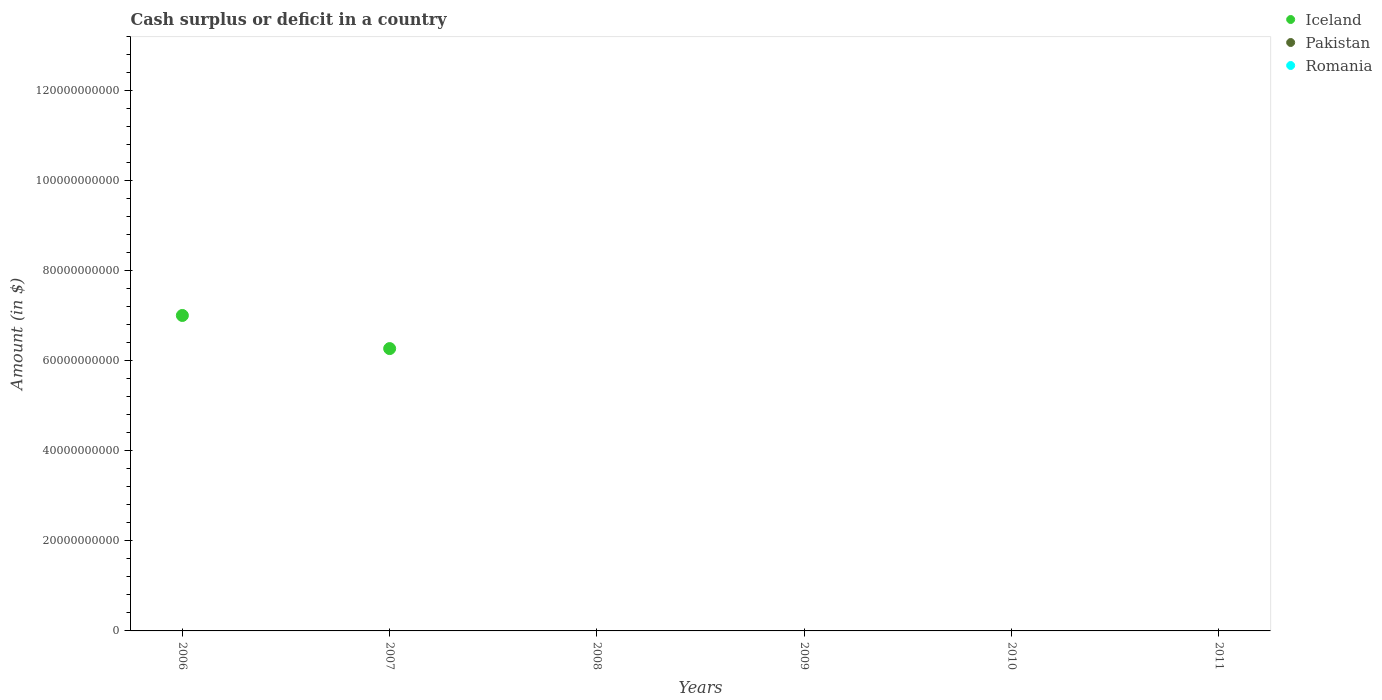Across all years, what is the maximum amount of cash surplus or deficit in Iceland?
Your answer should be very brief. 7.01e+1. What is the total amount of cash surplus or deficit in Romania in the graph?
Offer a terse response. 0. What is the difference between the amount of cash surplus or deficit in Romania in 2007 and the amount of cash surplus or deficit in Iceland in 2010?
Provide a succinct answer. 0. What is the average amount of cash surplus or deficit in Iceland per year?
Keep it short and to the point. 2.21e+1. Is the amount of cash surplus or deficit in Iceland in 2006 less than that in 2007?
Offer a very short reply. No. What is the difference between the highest and the lowest amount of cash surplus or deficit in Iceland?
Provide a short and direct response. 7.01e+1. Is it the case that in every year, the sum of the amount of cash surplus or deficit in Iceland and amount of cash surplus or deficit in Romania  is greater than the amount of cash surplus or deficit in Pakistan?
Give a very brief answer. No. Is the amount of cash surplus or deficit in Romania strictly greater than the amount of cash surplus or deficit in Iceland over the years?
Offer a very short reply. No. Is the amount of cash surplus or deficit in Pakistan strictly less than the amount of cash surplus or deficit in Romania over the years?
Keep it short and to the point. Yes. What is the difference between two consecutive major ticks on the Y-axis?
Your answer should be compact. 2.00e+1. Are the values on the major ticks of Y-axis written in scientific E-notation?
Make the answer very short. No. Does the graph contain any zero values?
Provide a succinct answer. Yes. Does the graph contain grids?
Make the answer very short. No. What is the title of the graph?
Offer a very short reply. Cash surplus or deficit in a country. What is the label or title of the Y-axis?
Your answer should be very brief. Amount (in $). What is the Amount (in $) of Iceland in 2006?
Offer a very short reply. 7.01e+1. What is the Amount (in $) of Pakistan in 2006?
Your answer should be very brief. 0. What is the Amount (in $) in Romania in 2006?
Give a very brief answer. 0. What is the Amount (in $) of Iceland in 2007?
Provide a short and direct response. 6.27e+1. What is the Amount (in $) of Pakistan in 2008?
Offer a very short reply. 0. What is the Amount (in $) in Iceland in 2009?
Ensure brevity in your answer.  0. What is the Amount (in $) in Pakistan in 2010?
Make the answer very short. 0. What is the Amount (in $) in Iceland in 2011?
Your answer should be compact. 0. What is the Amount (in $) of Pakistan in 2011?
Ensure brevity in your answer.  0. What is the Amount (in $) in Romania in 2011?
Offer a terse response. 0. Across all years, what is the maximum Amount (in $) of Iceland?
Keep it short and to the point. 7.01e+1. Across all years, what is the minimum Amount (in $) in Iceland?
Provide a short and direct response. 0. What is the total Amount (in $) of Iceland in the graph?
Offer a terse response. 1.33e+11. What is the total Amount (in $) of Romania in the graph?
Offer a terse response. 0. What is the difference between the Amount (in $) of Iceland in 2006 and that in 2007?
Your answer should be compact. 7.36e+09. What is the average Amount (in $) of Iceland per year?
Provide a succinct answer. 2.21e+1. What is the average Amount (in $) of Romania per year?
Offer a terse response. 0. What is the ratio of the Amount (in $) of Iceland in 2006 to that in 2007?
Keep it short and to the point. 1.12. What is the difference between the highest and the lowest Amount (in $) in Iceland?
Your answer should be compact. 7.01e+1. 